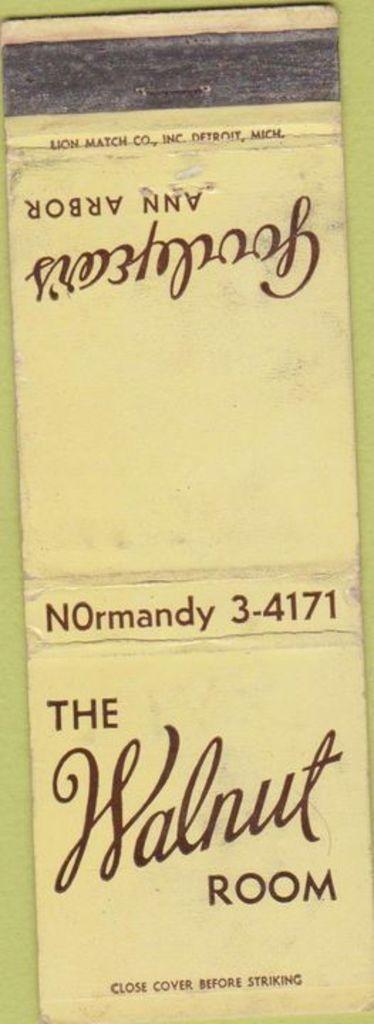What's the name of this place?
Offer a very short reply. The walnut room. What is the title of the book?
Your answer should be very brief. The walnut room. 